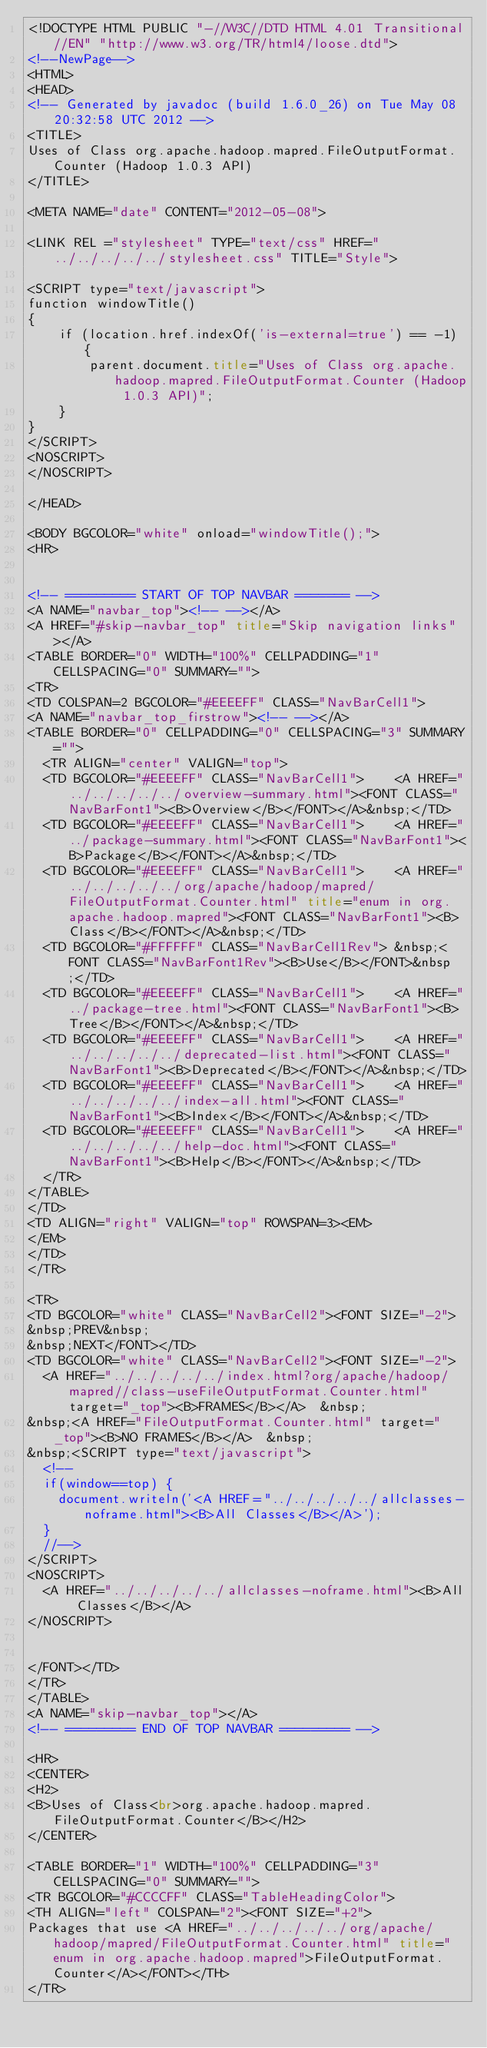Convert code to text. <code><loc_0><loc_0><loc_500><loc_500><_HTML_><!DOCTYPE HTML PUBLIC "-//W3C//DTD HTML 4.01 Transitional//EN" "http://www.w3.org/TR/html4/loose.dtd">
<!--NewPage-->
<HTML>
<HEAD>
<!-- Generated by javadoc (build 1.6.0_26) on Tue May 08 20:32:58 UTC 2012 -->
<TITLE>
Uses of Class org.apache.hadoop.mapred.FileOutputFormat.Counter (Hadoop 1.0.3 API)
</TITLE>

<META NAME="date" CONTENT="2012-05-08">

<LINK REL ="stylesheet" TYPE="text/css" HREF="../../../../../stylesheet.css" TITLE="Style">

<SCRIPT type="text/javascript">
function windowTitle()
{
    if (location.href.indexOf('is-external=true') == -1) {
        parent.document.title="Uses of Class org.apache.hadoop.mapred.FileOutputFormat.Counter (Hadoop 1.0.3 API)";
    }
}
</SCRIPT>
<NOSCRIPT>
</NOSCRIPT>

</HEAD>

<BODY BGCOLOR="white" onload="windowTitle();">
<HR>


<!-- ========= START OF TOP NAVBAR ======= -->
<A NAME="navbar_top"><!-- --></A>
<A HREF="#skip-navbar_top" title="Skip navigation links"></A>
<TABLE BORDER="0" WIDTH="100%" CELLPADDING="1" CELLSPACING="0" SUMMARY="">
<TR>
<TD COLSPAN=2 BGCOLOR="#EEEEFF" CLASS="NavBarCell1">
<A NAME="navbar_top_firstrow"><!-- --></A>
<TABLE BORDER="0" CELLPADDING="0" CELLSPACING="3" SUMMARY="">
  <TR ALIGN="center" VALIGN="top">
  <TD BGCOLOR="#EEEEFF" CLASS="NavBarCell1">    <A HREF="../../../../../overview-summary.html"><FONT CLASS="NavBarFont1"><B>Overview</B></FONT></A>&nbsp;</TD>
  <TD BGCOLOR="#EEEEFF" CLASS="NavBarCell1">    <A HREF="../package-summary.html"><FONT CLASS="NavBarFont1"><B>Package</B></FONT></A>&nbsp;</TD>
  <TD BGCOLOR="#EEEEFF" CLASS="NavBarCell1">    <A HREF="../../../../../org/apache/hadoop/mapred/FileOutputFormat.Counter.html" title="enum in org.apache.hadoop.mapred"><FONT CLASS="NavBarFont1"><B>Class</B></FONT></A>&nbsp;</TD>
  <TD BGCOLOR="#FFFFFF" CLASS="NavBarCell1Rev"> &nbsp;<FONT CLASS="NavBarFont1Rev"><B>Use</B></FONT>&nbsp;</TD>
  <TD BGCOLOR="#EEEEFF" CLASS="NavBarCell1">    <A HREF="../package-tree.html"><FONT CLASS="NavBarFont1"><B>Tree</B></FONT></A>&nbsp;</TD>
  <TD BGCOLOR="#EEEEFF" CLASS="NavBarCell1">    <A HREF="../../../../../deprecated-list.html"><FONT CLASS="NavBarFont1"><B>Deprecated</B></FONT></A>&nbsp;</TD>
  <TD BGCOLOR="#EEEEFF" CLASS="NavBarCell1">    <A HREF="../../../../../index-all.html"><FONT CLASS="NavBarFont1"><B>Index</B></FONT></A>&nbsp;</TD>
  <TD BGCOLOR="#EEEEFF" CLASS="NavBarCell1">    <A HREF="../../../../../help-doc.html"><FONT CLASS="NavBarFont1"><B>Help</B></FONT></A>&nbsp;</TD>
  </TR>
</TABLE>
</TD>
<TD ALIGN="right" VALIGN="top" ROWSPAN=3><EM>
</EM>
</TD>
</TR>

<TR>
<TD BGCOLOR="white" CLASS="NavBarCell2"><FONT SIZE="-2">
&nbsp;PREV&nbsp;
&nbsp;NEXT</FONT></TD>
<TD BGCOLOR="white" CLASS="NavBarCell2"><FONT SIZE="-2">
  <A HREF="../../../../../index.html?org/apache/hadoop/mapred//class-useFileOutputFormat.Counter.html" target="_top"><B>FRAMES</B></A>  &nbsp;
&nbsp;<A HREF="FileOutputFormat.Counter.html" target="_top"><B>NO FRAMES</B></A>  &nbsp;
&nbsp;<SCRIPT type="text/javascript">
  <!--
  if(window==top) {
    document.writeln('<A HREF="../../../../../allclasses-noframe.html"><B>All Classes</B></A>');
  }
  //-->
</SCRIPT>
<NOSCRIPT>
  <A HREF="../../../../../allclasses-noframe.html"><B>All Classes</B></A>
</NOSCRIPT>


</FONT></TD>
</TR>
</TABLE>
<A NAME="skip-navbar_top"></A>
<!-- ========= END OF TOP NAVBAR ========= -->

<HR>
<CENTER>
<H2>
<B>Uses of Class<br>org.apache.hadoop.mapred.FileOutputFormat.Counter</B></H2>
</CENTER>

<TABLE BORDER="1" WIDTH="100%" CELLPADDING="3" CELLSPACING="0" SUMMARY="">
<TR BGCOLOR="#CCCCFF" CLASS="TableHeadingColor">
<TH ALIGN="left" COLSPAN="2"><FONT SIZE="+2">
Packages that use <A HREF="../../../../../org/apache/hadoop/mapred/FileOutputFormat.Counter.html" title="enum in org.apache.hadoop.mapred">FileOutputFormat.Counter</A></FONT></TH>
</TR></code> 